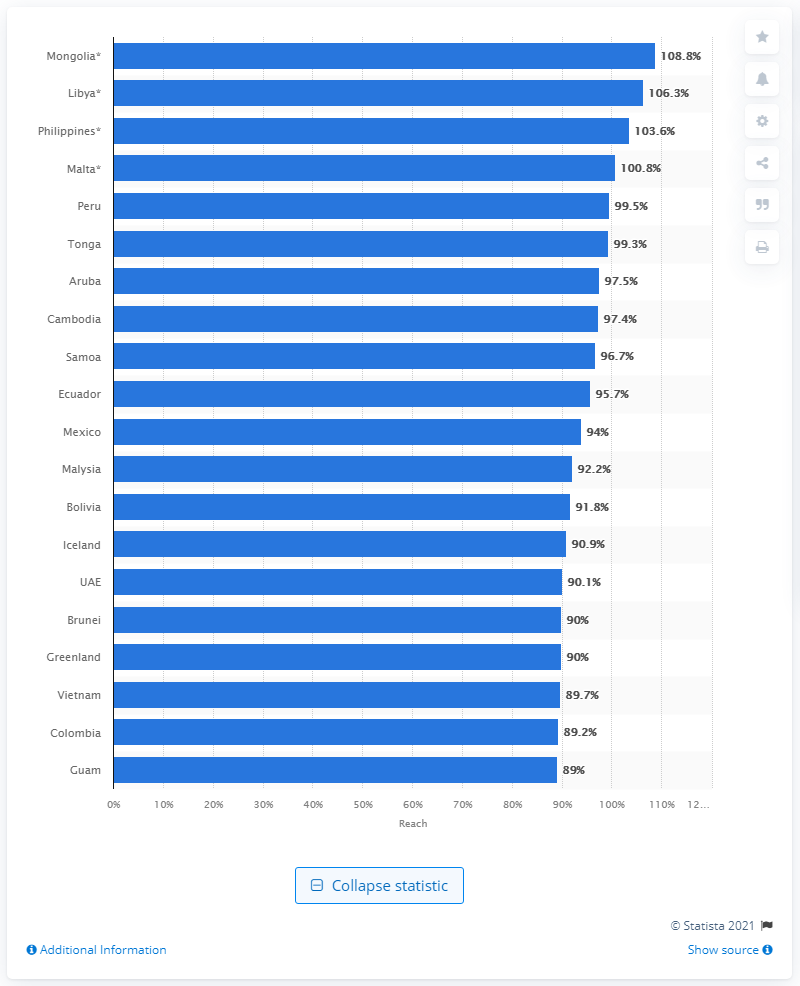Point out several critical features in this image. According to data, Tonga had the highest rate of Facebook audience reach among all countries. 